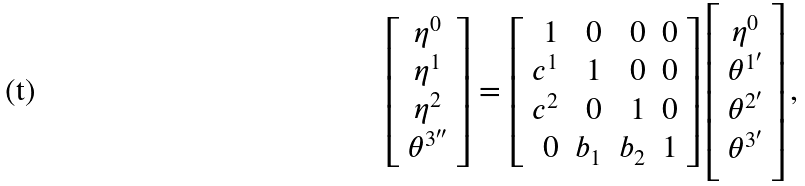<formula> <loc_0><loc_0><loc_500><loc_500>\left [ \begin{array} { c c c c } \eta ^ { 0 } \\ \eta ^ { 1 } \\ \eta ^ { 2 } \\ \theta ^ { 3 ^ { \prime \prime } } \end{array} \right ] = \left [ \begin{array} { r r r r } 1 & 0 & 0 & 0 \\ c ^ { 1 } & 1 & 0 & 0 \\ c ^ { 2 } & 0 & 1 & 0 \\ 0 & b _ { 1 } & b _ { 2 } & 1 \end{array} \right ] \left [ \begin{array} { c c c c } \eta ^ { 0 } \\ \theta ^ { 1 ^ { \prime } } \\ \theta ^ { 2 ^ { \prime } } \\ \theta ^ { 3 ^ { \prime } } \end{array} \right ] ,</formula> 